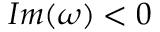Convert formula to latex. <formula><loc_0><loc_0><loc_500><loc_500>I m ( \omega ) < 0</formula> 